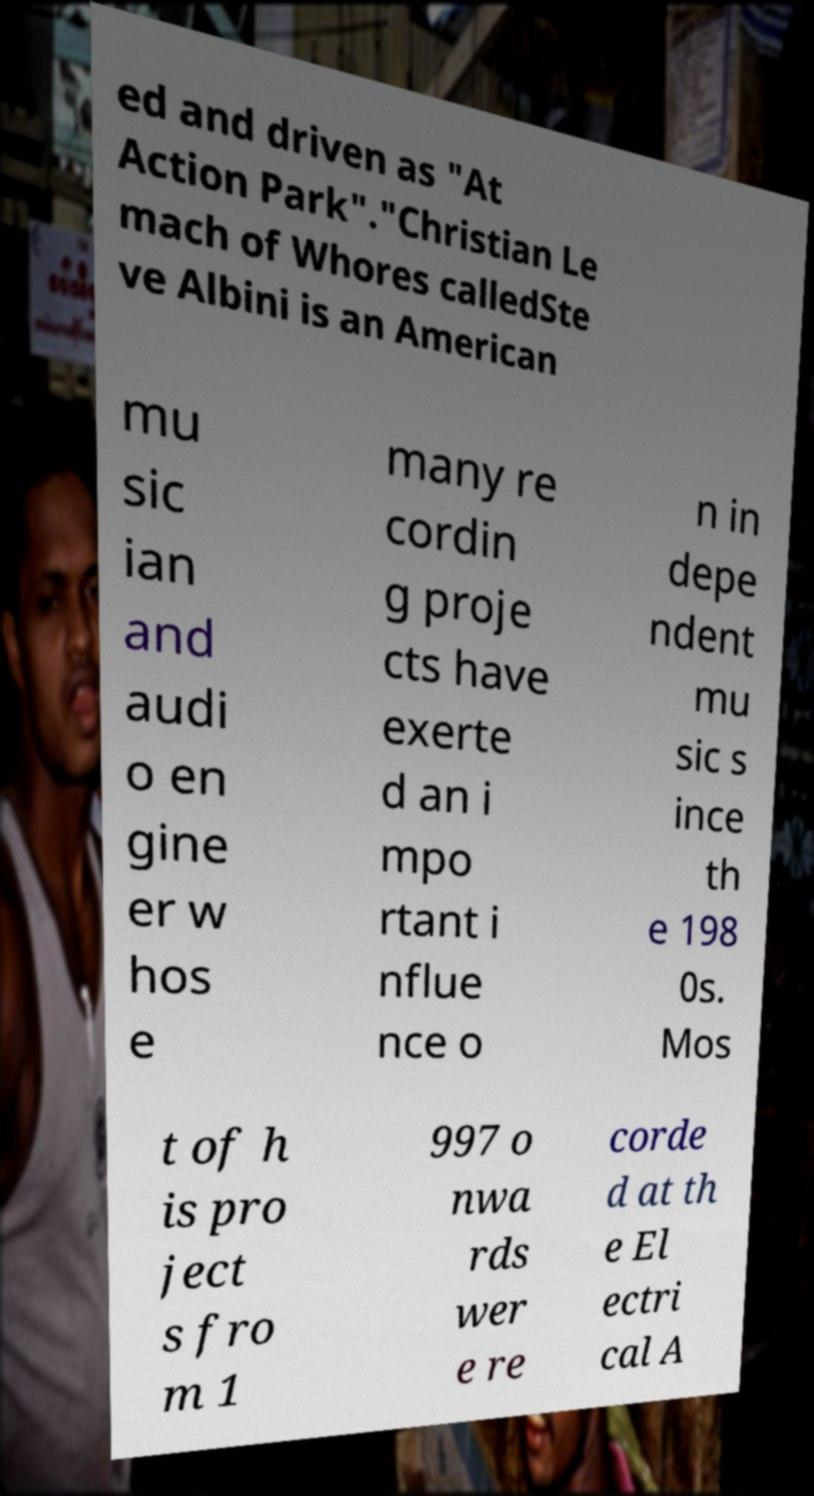Can you accurately transcribe the text from the provided image for me? ed and driven as "At Action Park"."Christian Le mach of Whores calledSte ve Albini is an American mu sic ian and audi o en gine er w hos e many re cordin g proje cts have exerte d an i mpo rtant i nflue nce o n in depe ndent mu sic s ince th e 198 0s. Mos t of h is pro ject s fro m 1 997 o nwa rds wer e re corde d at th e El ectri cal A 